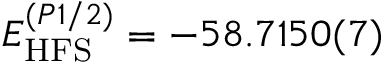Convert formula to latex. <formula><loc_0><loc_0><loc_500><loc_500>E _ { H F S } ^ { ( P 1 / 2 ) } = - 5 8 . 7 1 5 0 ( 7 )</formula> 